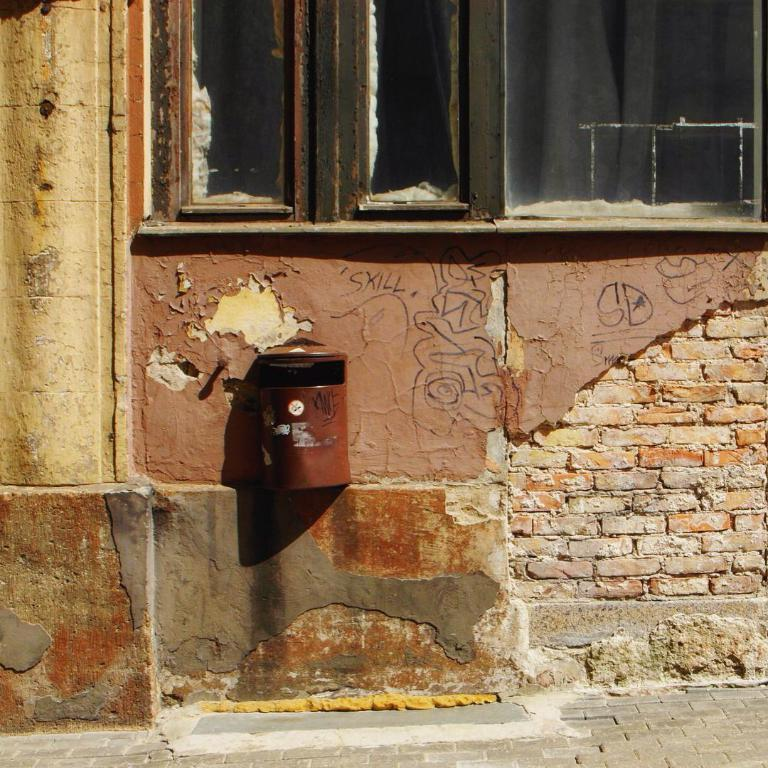What object is attached to the wall in the image? There is a mailbox on the wall in the image. What can be seen through the windows in the image? The presence of windows suggests that there may be a view of the outdoors or other rooms, but the specific view cannot be determined from the provided facts. Can you see any books or milk on the seashore in the image? There is no seashore, books, or milk present in the image. 